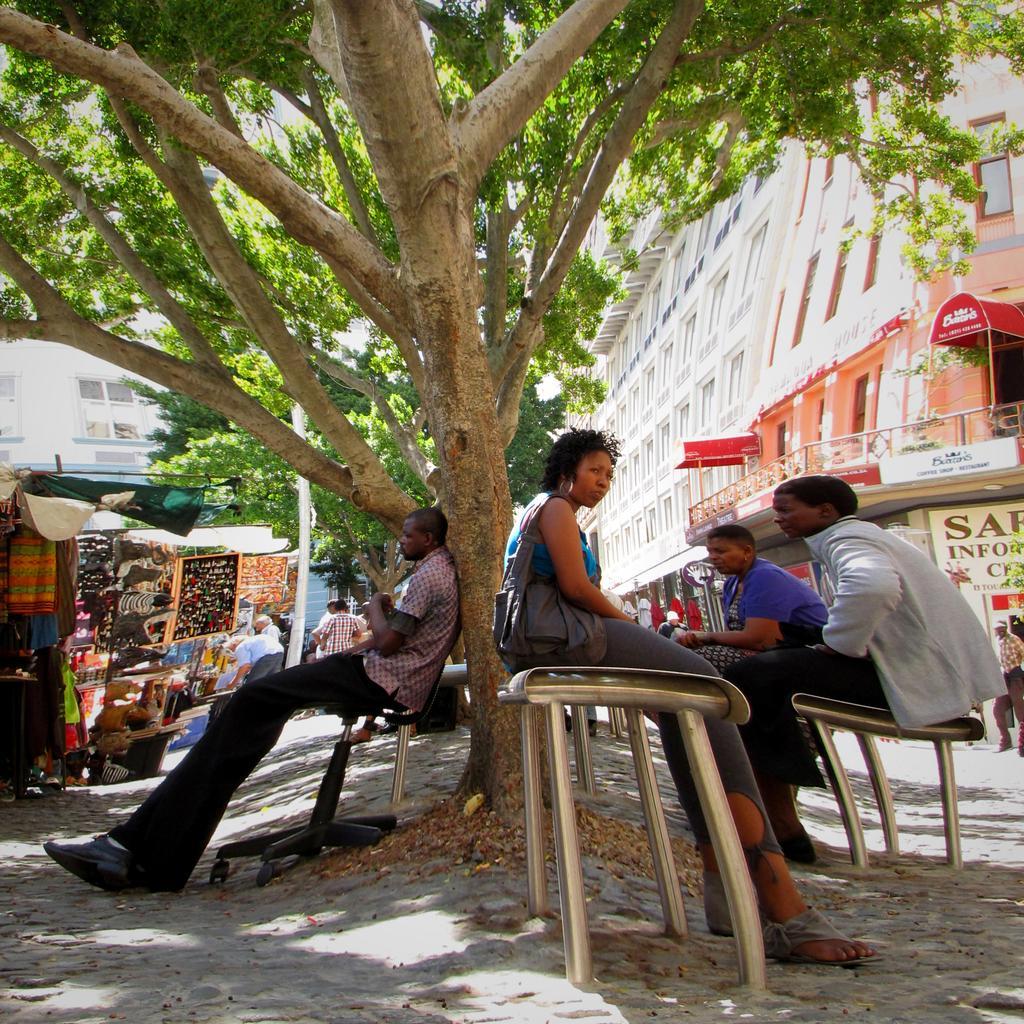Please provide a concise description of this image. There are few people sitting under a tree behind them there is a shopping stall and building on the opposite side. 